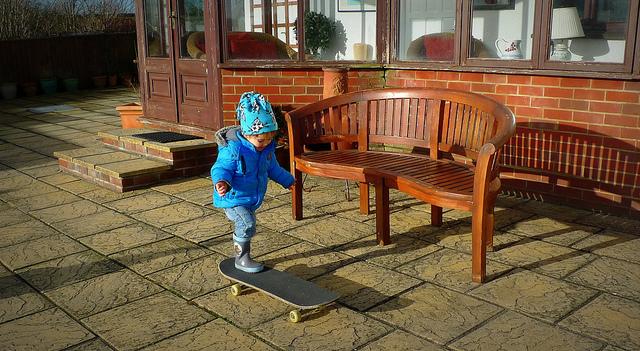What color is the kid's coat?
Short answer required. Blue. What is the kid stepping on?
Write a very short answer. Skateboard. How many benches?
Give a very brief answer. 1. 